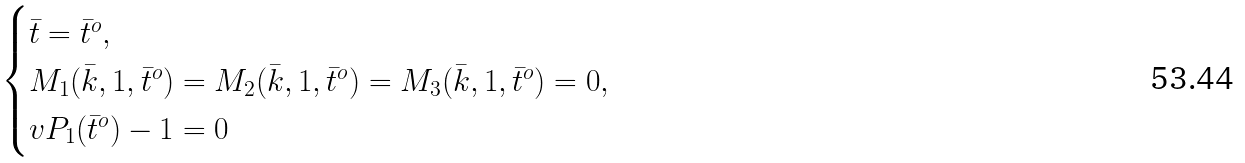<formula> <loc_0><loc_0><loc_500><loc_500>\begin{cases} \bar { t } = \bar { t } ^ { o } , \\ M _ { 1 } ( \bar { k } , 1 , \bar { t } ^ { o } ) = M _ { 2 } ( \bar { k } , 1 , \bar { t } ^ { o } ) = M _ { 3 } ( \bar { k } , 1 , \bar { t } ^ { o } ) = 0 , \\ v P _ { 1 } ( \bar { t } ^ { o } ) - 1 = 0 \end{cases}</formula> 